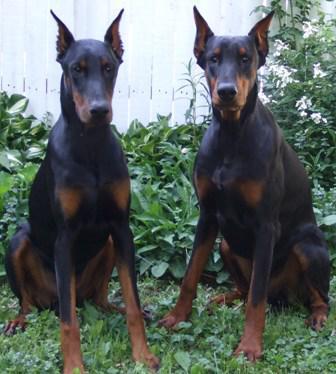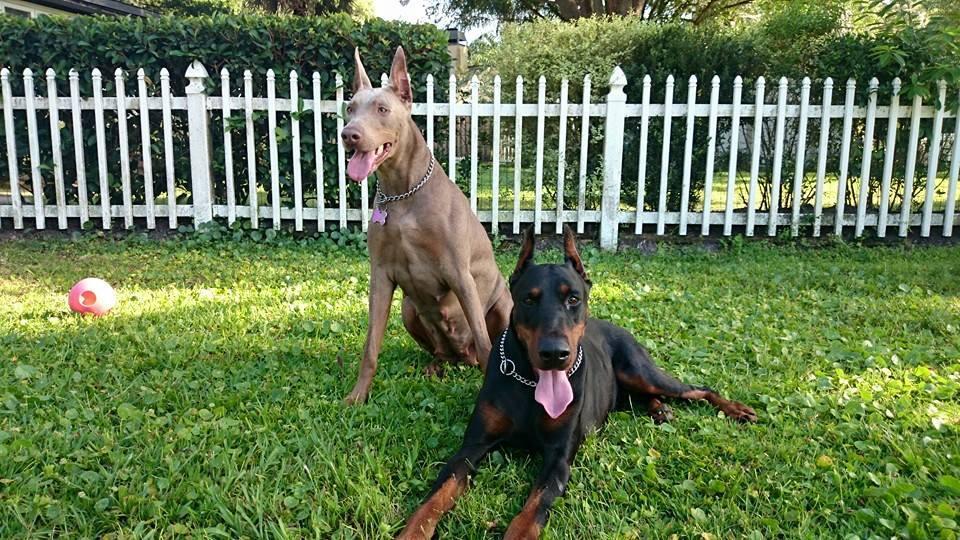The first image is the image on the left, the second image is the image on the right. Considering the images on both sides, is "Three dogs are present." valid? Answer yes or no. No. The first image is the image on the left, the second image is the image on the right. Given the left and right images, does the statement "There are an equal number of dogs in each image." hold true? Answer yes or no. Yes. 